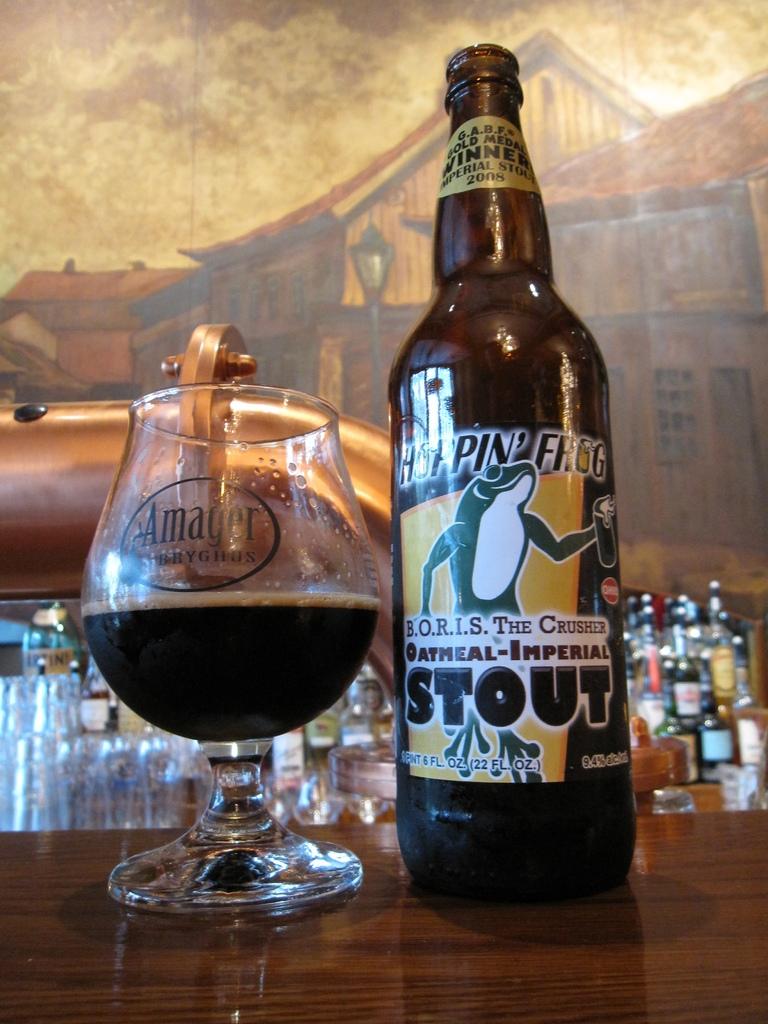What kind of drink is this?
Offer a very short reply. Stout. How many ounces is this beer?
Keep it short and to the point. 22. 